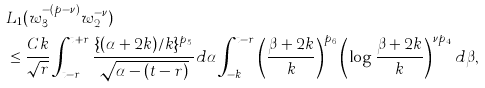Convert formula to latex. <formula><loc_0><loc_0><loc_500><loc_500>& L _ { 1 } ( w _ { 3 } ^ { - ( p - \nu ) } w _ { 2 } ^ { - \nu } ) \\ & \leq \frac { C k } { \sqrt { r } } \int _ { t - r } ^ { t + r } \frac { \{ ( \alpha + 2 k ) / k \} ^ { p _ { 5 } } } { \sqrt { \alpha - ( t - r ) } } d \alpha \int _ { - k } ^ { t - r } \left ( \frac { \beta + 2 k } { k } \right ) ^ { p _ { 6 } } \left ( \log \frac { \beta + 2 k } { k } \right ) ^ { \nu p _ { 4 } } d \beta ,</formula> 